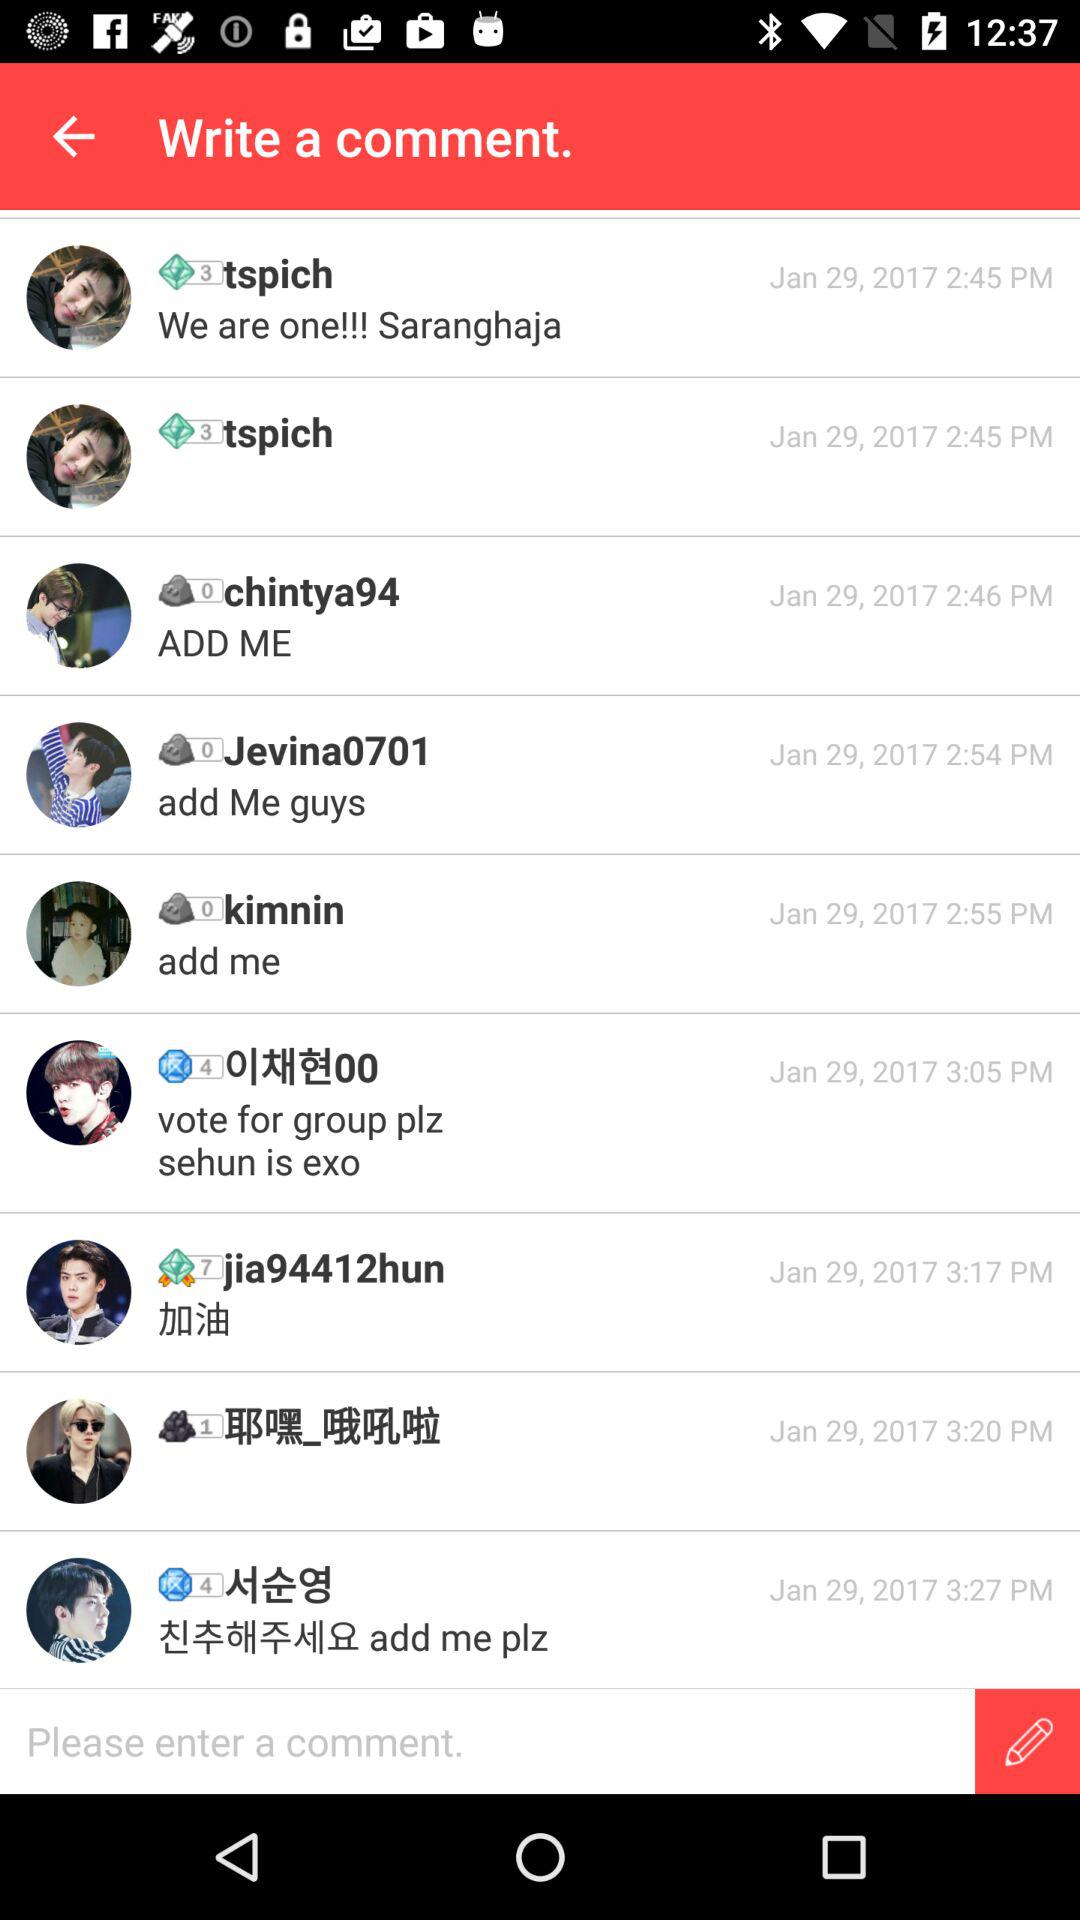When was the comment posted by chintya94? The comment was posted on January 29, 2017 at 2:46 PM. 